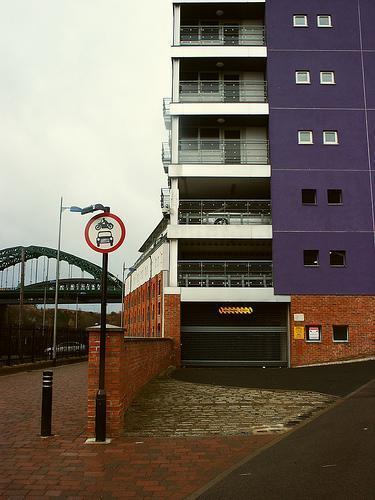How many cars are seen?
Give a very brief answer. 2. 